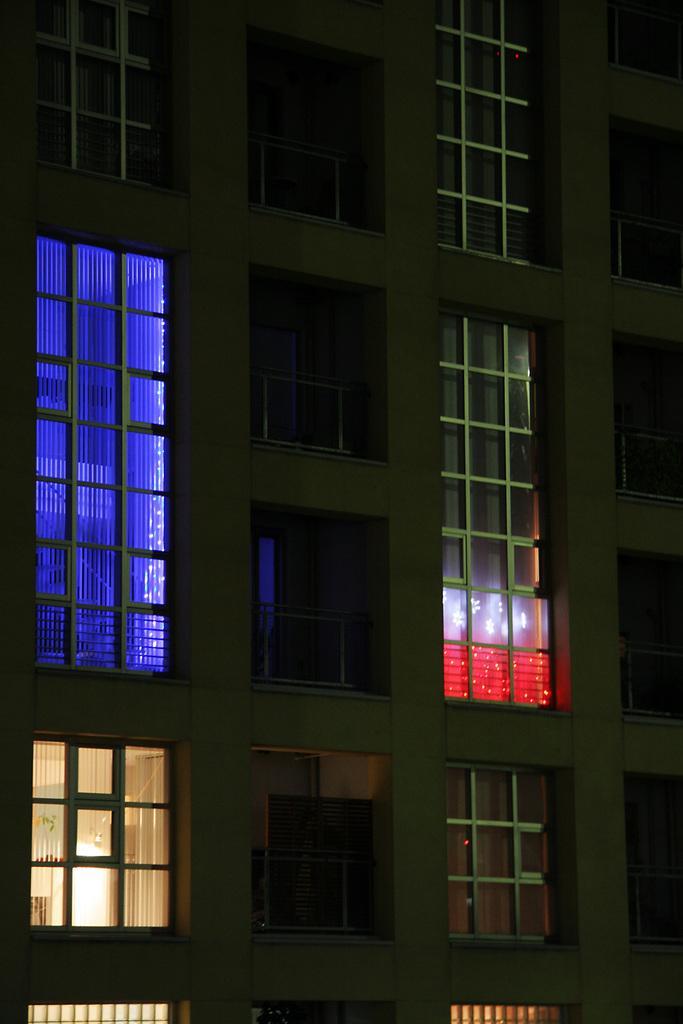In one or two sentences, can you explain what this image depicts? In this image we can see a building and windows. 